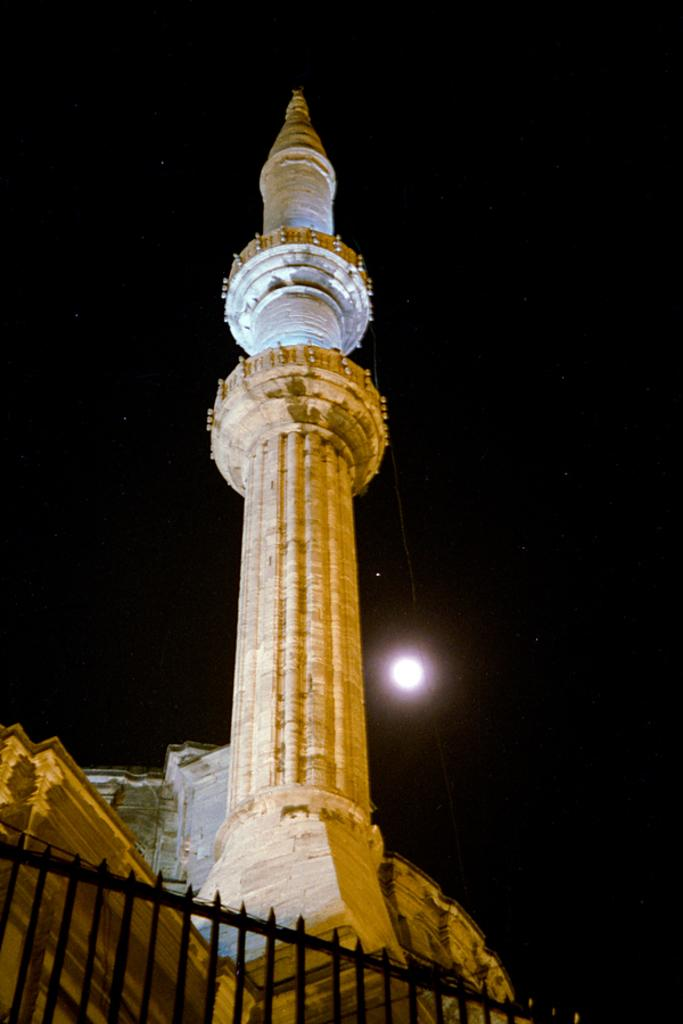What structure is the main focus of the image? There is a tower in the image. What other object can be seen in the image? There is a fence in the image. How would you describe the sky in the image? The sky is dark in the image. What celestial body is visible in the image? The moon is visible in the image. What type of flame can be seen at the base of the tower in the image? There is no flame present at the base of the tower in the image. 